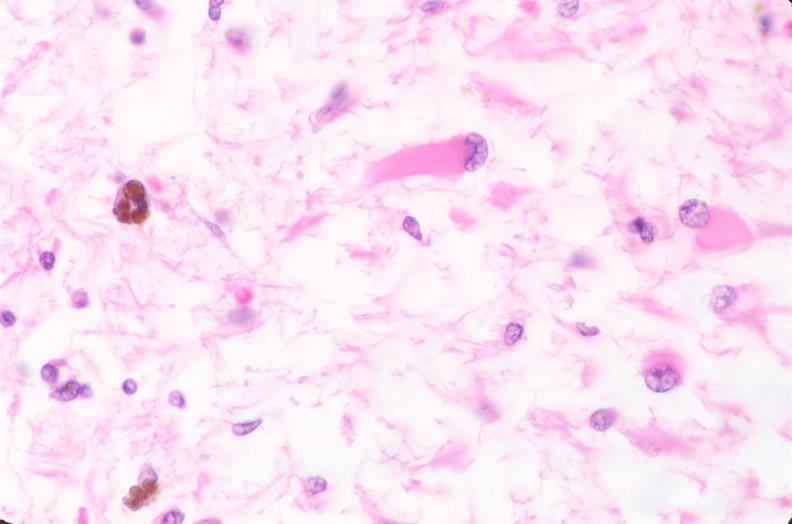s nervous present?
Answer the question using a single word or phrase. Yes 